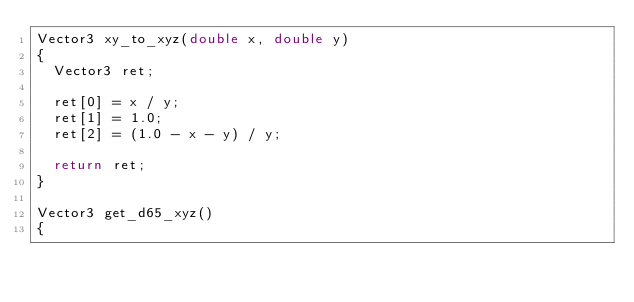Convert code to text. <code><loc_0><loc_0><loc_500><loc_500><_C++_>Vector3 xy_to_xyz(double x, double y)
{
	Vector3 ret;

	ret[0] = x / y;
	ret[1] = 1.0;
	ret[2] = (1.0 - x - y) / y;

	return ret;
}

Vector3 get_d65_xyz()
{</code> 